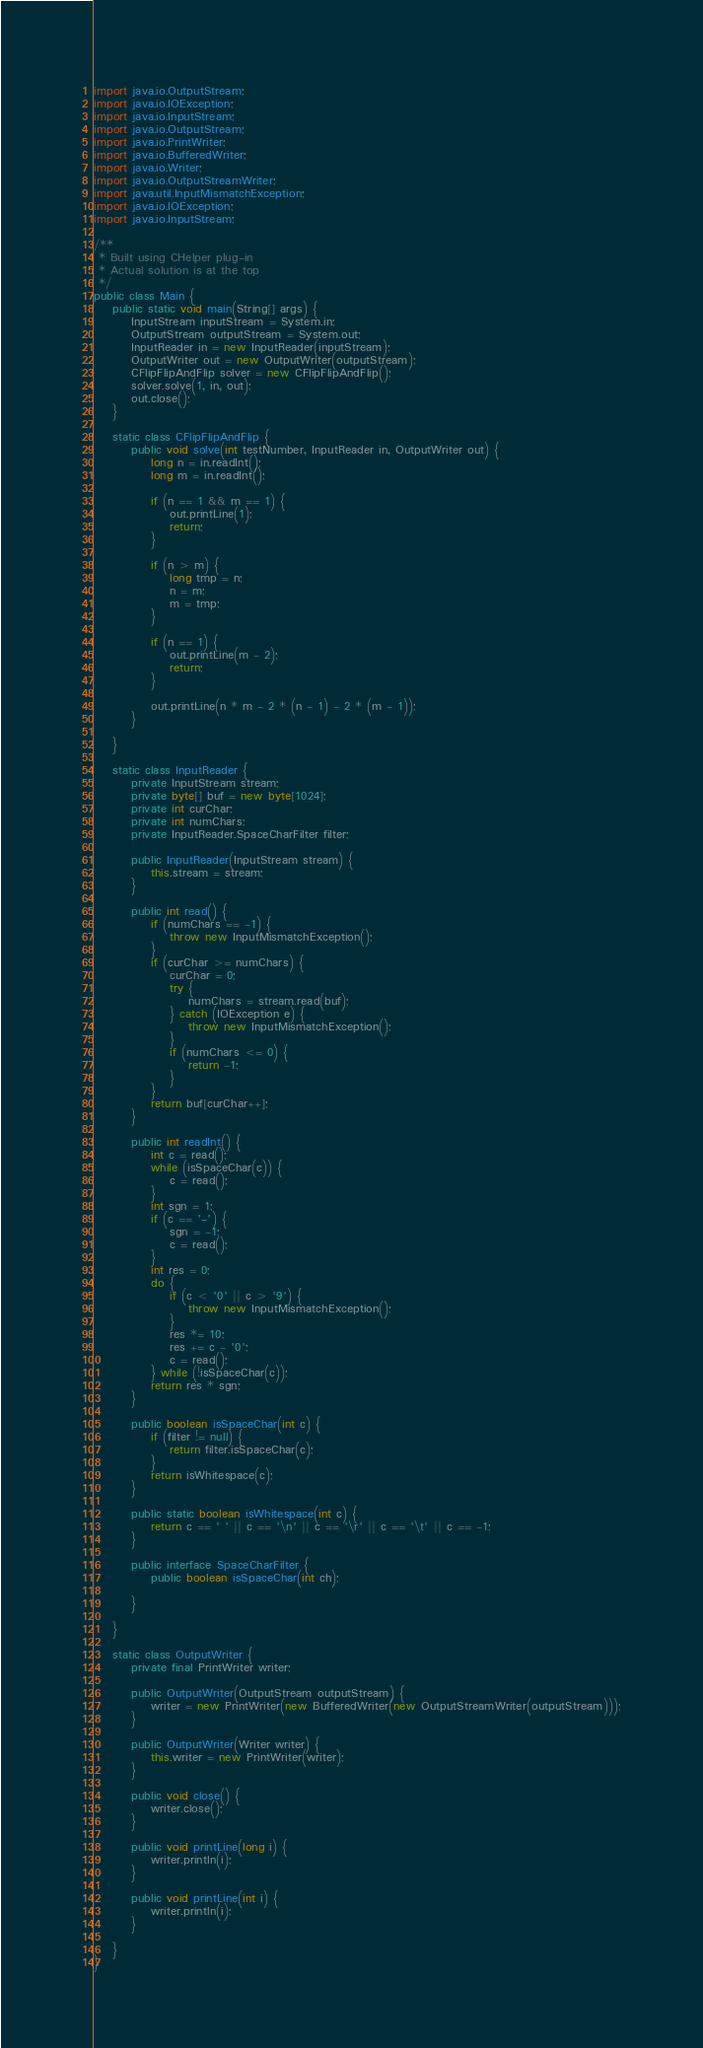<code> <loc_0><loc_0><loc_500><loc_500><_Java_>import java.io.OutputStream;
import java.io.IOException;
import java.io.InputStream;
import java.io.OutputStream;
import java.io.PrintWriter;
import java.io.BufferedWriter;
import java.io.Writer;
import java.io.OutputStreamWriter;
import java.util.InputMismatchException;
import java.io.IOException;
import java.io.InputStream;

/**
 * Built using CHelper plug-in
 * Actual solution is at the top
 */
public class Main {
    public static void main(String[] args) {
        InputStream inputStream = System.in;
        OutputStream outputStream = System.out;
        InputReader in = new InputReader(inputStream);
        OutputWriter out = new OutputWriter(outputStream);
        CFlipFlipAndFlip solver = new CFlipFlipAndFlip();
        solver.solve(1, in, out);
        out.close();
    }

    static class CFlipFlipAndFlip {
        public void solve(int testNumber, InputReader in, OutputWriter out) {
            long n = in.readInt();
            long m = in.readInt();

            if (n == 1 && m == 1) {
                out.printLine(1);
                return;
            }

            if (n > m) {
                long tmp = n;
                n = m;
                m = tmp;
            }

            if (n == 1) {
                out.printLine(m - 2);
                return;
            }

            out.printLine(n * m - 2 * (n - 1) - 2 * (m - 1));
        }

    }

    static class InputReader {
        private InputStream stream;
        private byte[] buf = new byte[1024];
        private int curChar;
        private int numChars;
        private InputReader.SpaceCharFilter filter;

        public InputReader(InputStream stream) {
            this.stream = stream;
        }

        public int read() {
            if (numChars == -1) {
                throw new InputMismatchException();
            }
            if (curChar >= numChars) {
                curChar = 0;
                try {
                    numChars = stream.read(buf);
                } catch (IOException e) {
                    throw new InputMismatchException();
                }
                if (numChars <= 0) {
                    return -1;
                }
            }
            return buf[curChar++];
        }

        public int readInt() {
            int c = read();
            while (isSpaceChar(c)) {
                c = read();
            }
            int sgn = 1;
            if (c == '-') {
                sgn = -1;
                c = read();
            }
            int res = 0;
            do {
                if (c < '0' || c > '9') {
                    throw new InputMismatchException();
                }
                res *= 10;
                res += c - '0';
                c = read();
            } while (!isSpaceChar(c));
            return res * sgn;
        }

        public boolean isSpaceChar(int c) {
            if (filter != null) {
                return filter.isSpaceChar(c);
            }
            return isWhitespace(c);
        }

        public static boolean isWhitespace(int c) {
            return c == ' ' || c == '\n' || c == '\r' || c == '\t' || c == -1;
        }

        public interface SpaceCharFilter {
            public boolean isSpaceChar(int ch);

        }

    }

    static class OutputWriter {
        private final PrintWriter writer;

        public OutputWriter(OutputStream outputStream) {
            writer = new PrintWriter(new BufferedWriter(new OutputStreamWriter(outputStream)));
        }

        public OutputWriter(Writer writer) {
            this.writer = new PrintWriter(writer);
        }

        public void close() {
            writer.close();
        }

        public void printLine(long i) {
            writer.println(i);
        }

        public void printLine(int i) {
            writer.println(i);
        }

    }
}

</code> 